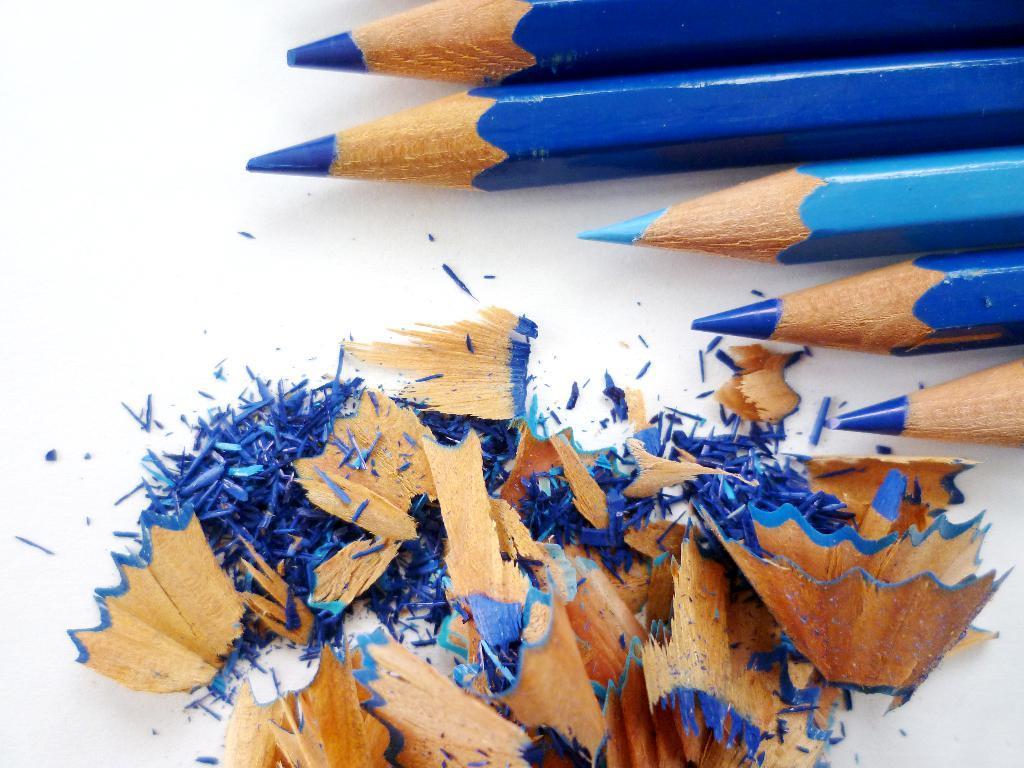Describe this image in one or two sentences. In this image I see 5 pencils which are of blue in color and I see the dust over here and all these things are on the white surface. 